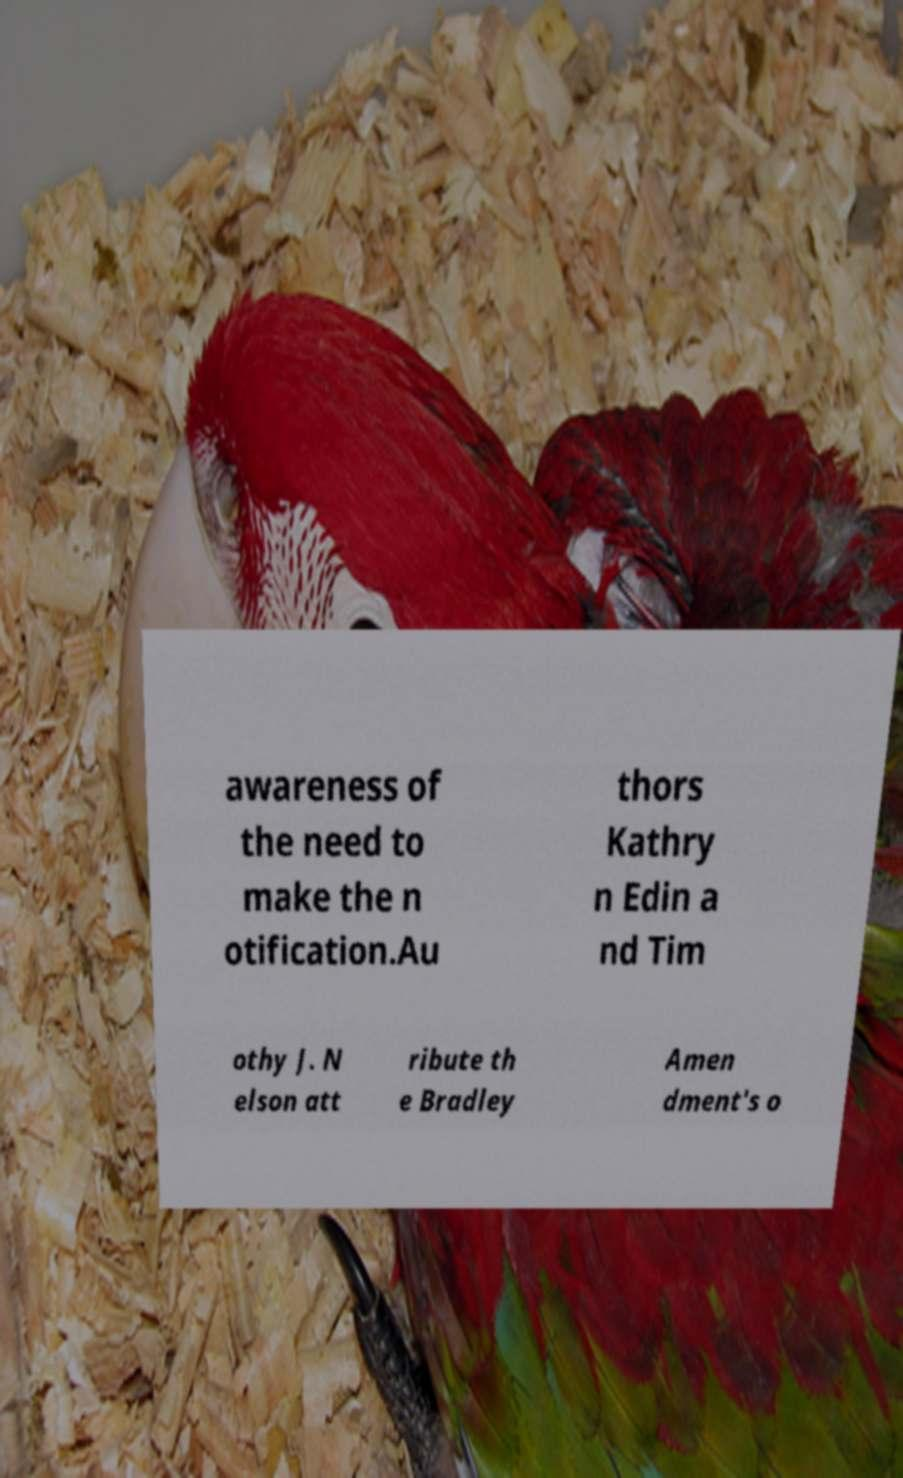For documentation purposes, I need the text within this image transcribed. Could you provide that? awareness of the need to make the n otification.Au thors Kathry n Edin a nd Tim othy J. N elson att ribute th e Bradley Amen dment's o 